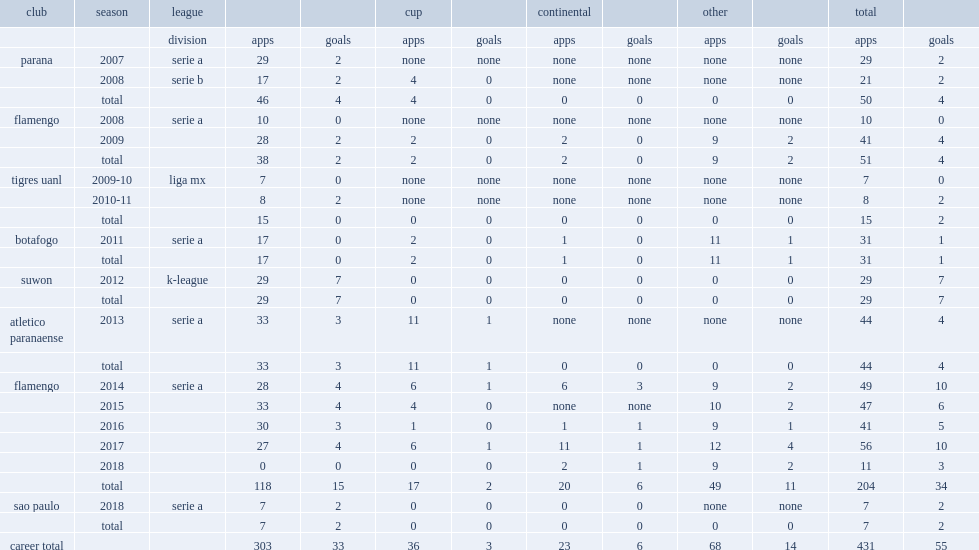Can you give me this table as a dict? {'header': ['club', 'season', 'league', '', '', 'cup', '', 'continental', '', 'other', '', 'total', ''], 'rows': [['', '', 'division', 'apps', 'goals', 'apps', 'goals', 'apps', 'goals', 'apps', 'goals', 'apps', 'goals'], ['parana', '2007', 'serie a', '29', '2', 'none', 'none', 'none', 'none', 'none', 'none', '29', '2'], ['', '2008', 'serie b', '17', '2', '4', '0', 'none', 'none', 'none', 'none', '21', '2'], ['', 'total', '', '46', '4', '4', '0', '0', '0', '0', '0', '50', '4'], ['flamengo', '2008', 'serie a', '10', '0', 'none', 'none', 'none', 'none', 'none', 'none', '10', '0'], ['', '2009', '', '28', '2', '2', '0', '2', '0', '9', '2', '41', '4'], ['', 'total', '', '38', '2', '2', '0', '2', '0', '9', '2', '51', '4'], ['tigres uanl', '2009-10', 'liga mx', '7', '0', 'none', 'none', 'none', 'none', 'none', 'none', '7', '0'], ['', '2010-11', '', '8', '2', 'none', 'none', 'none', 'none', 'none', 'none', '8', '2'], ['', 'total', '', '15', '0', '0', '0', '0', '0', '0', '0', '15', '2'], ['botafogo', '2011', 'serie a', '17', '0', '2', '0', '1', '0', '11', '1', '31', '1'], ['', 'total', '', '17', '0', '2', '0', '1', '0', '11', '1', '31', '1'], ['suwon', '2012', 'k-league', '29', '7', '0', '0', '0', '0', '0', '0', '29', '7'], ['', 'total', '', '29', '7', '0', '0', '0', '0', '0', '0', '29', '7'], ['atletico paranaense', '2013', 'serie a', '33', '3', '11', '1', 'none', 'none', 'none', 'none', '44', '4'], ['', 'total', '', '33', '3', '11', '1', '0', '0', '0', '0', '44', '4'], ['flamengo', '2014', 'serie a', '28', '4', '6', '1', '6', '3', '9', '2', '49', '10'], ['', '2015', '', '33', '4', '4', '0', 'none', 'none', '10', '2', '47', '6'], ['', '2016', '', '30', '3', '1', '0', '1', '1', '9', '1', '41', '5'], ['', '2017', '', '27', '4', '6', '1', '11', '1', '12', '4', '56', '10'], ['', '2018', '', '0', '0', '0', '0', '2', '1', '9', '2', '11', '3'], ['', 'total', '', '118', '15', '17', '2', '20', '6', '49', '11', '204', '34'], ['sao paulo', '2018', 'serie a', '7', '2', '0', '0', '0', '0', 'none', 'none', '7', '2'], ['', 'total', '', '7', '2', '0', '0', '0', '0', '0', '0', '7', '2'], ['career total', '', '', '303', '33', '36', '3', '23', '6', '68', '14', '431', '55']]} In 2008, which division did the everton cardoso da silva debute for flamengo? Serie a. 